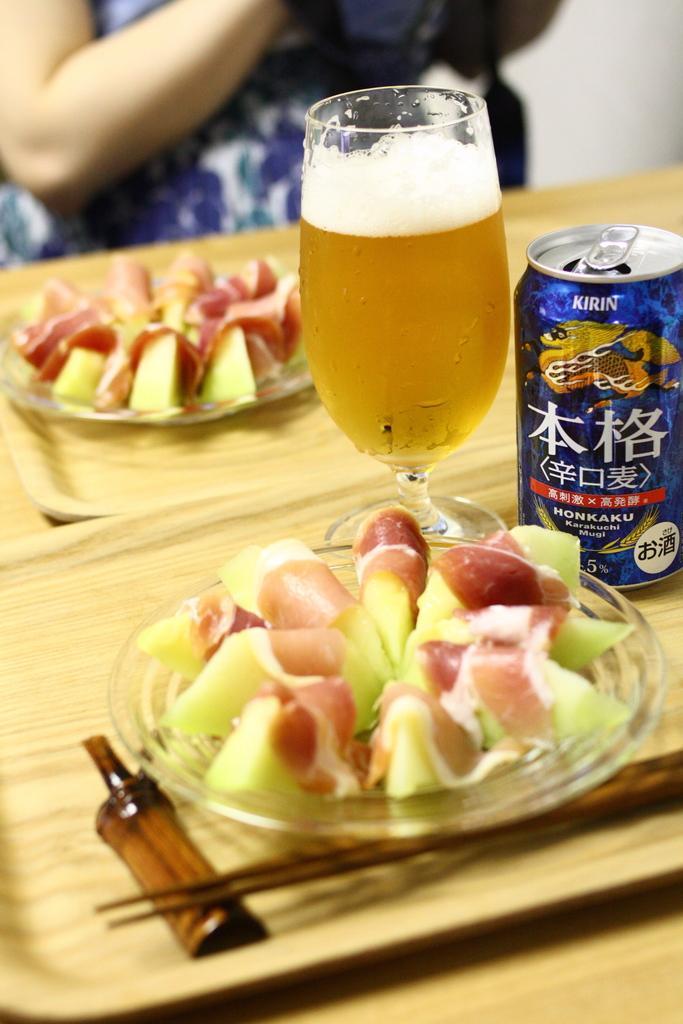Could you give a brief overview of what you see in this image? In this image we can see there are two plates of food items in trays and there is a glass, a can and chopsticks on it, behind it a person is sitting. 